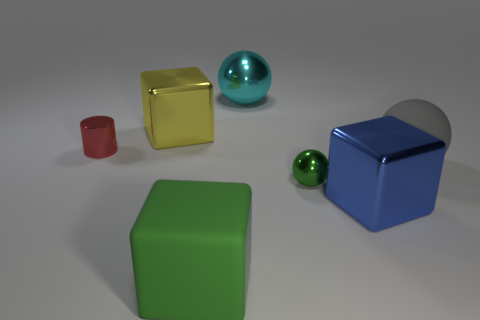Add 2 big cyan things. How many objects exist? 9 Subtract all balls. How many objects are left? 4 Subtract 1 red cylinders. How many objects are left? 6 Subtract all large metal objects. Subtract all big green objects. How many objects are left? 3 Add 3 big cyan objects. How many big cyan objects are left? 4 Add 2 large matte spheres. How many large matte spheres exist? 3 